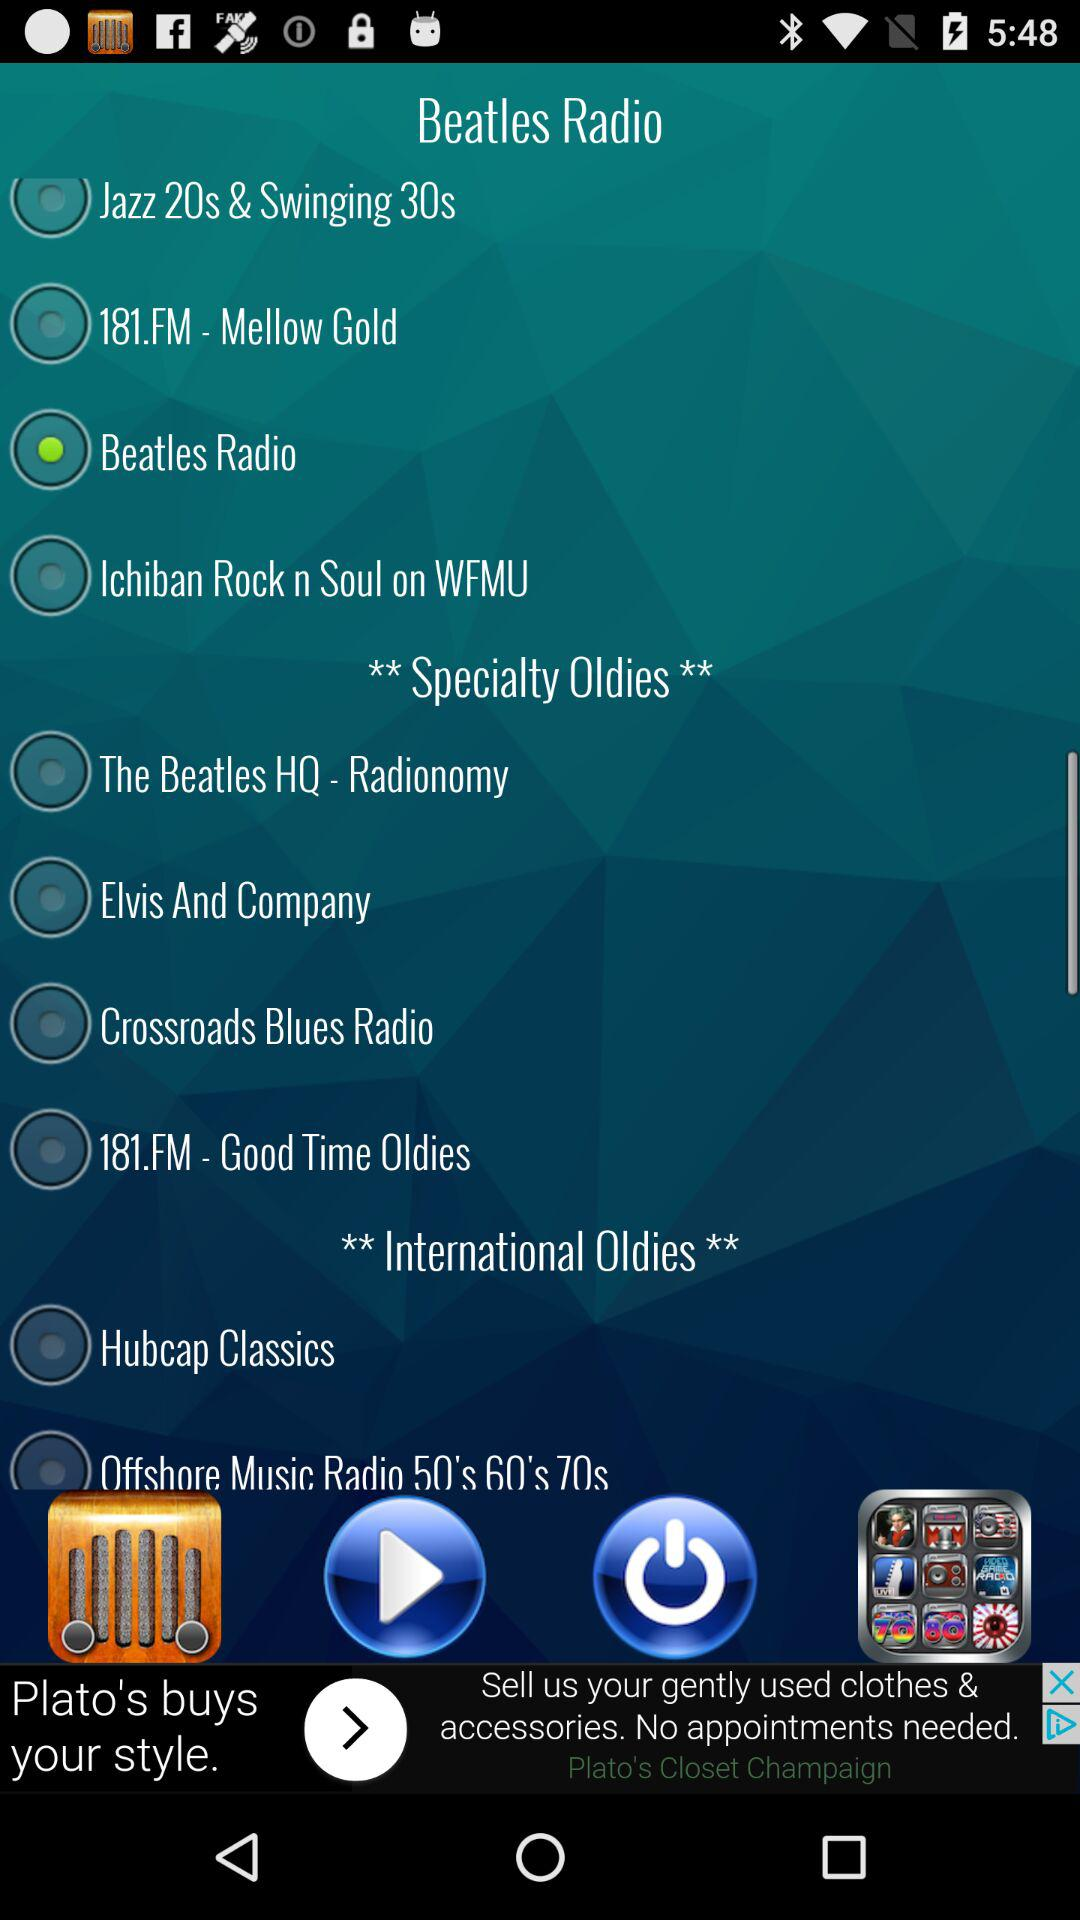What is the functionality of the icons in the top bar? The top bar includes several icons: three horizontal lines which might be a menu or settings option, a Facebook icon which suggests a feature to share or connect via Facebook, and an icon resembling a chess piece, likely indicating a games or entertainment feature within the app. 